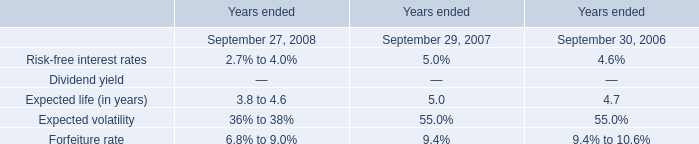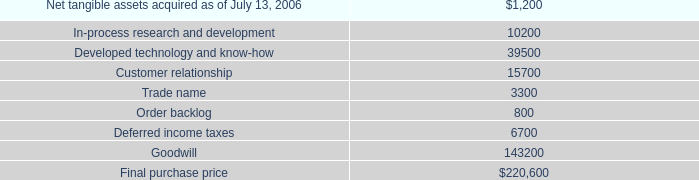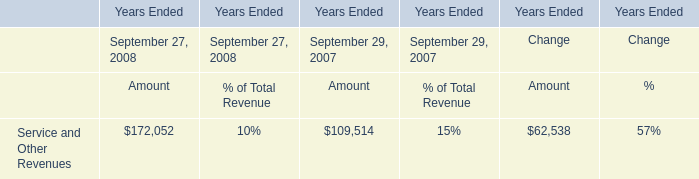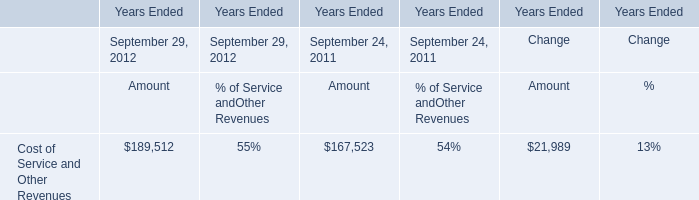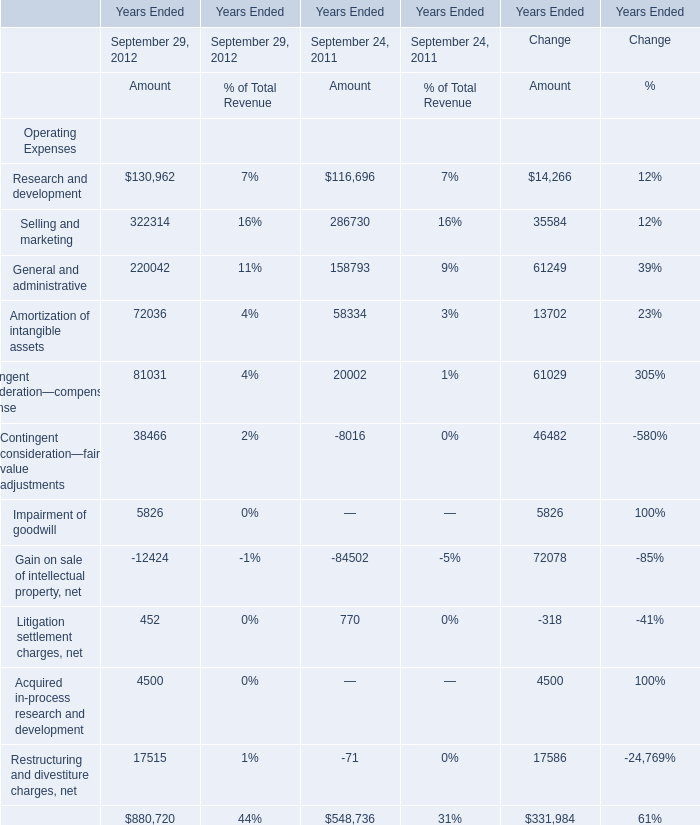How many kinds of Amount are greater than 0 in 2012? 
Answer: 10. 